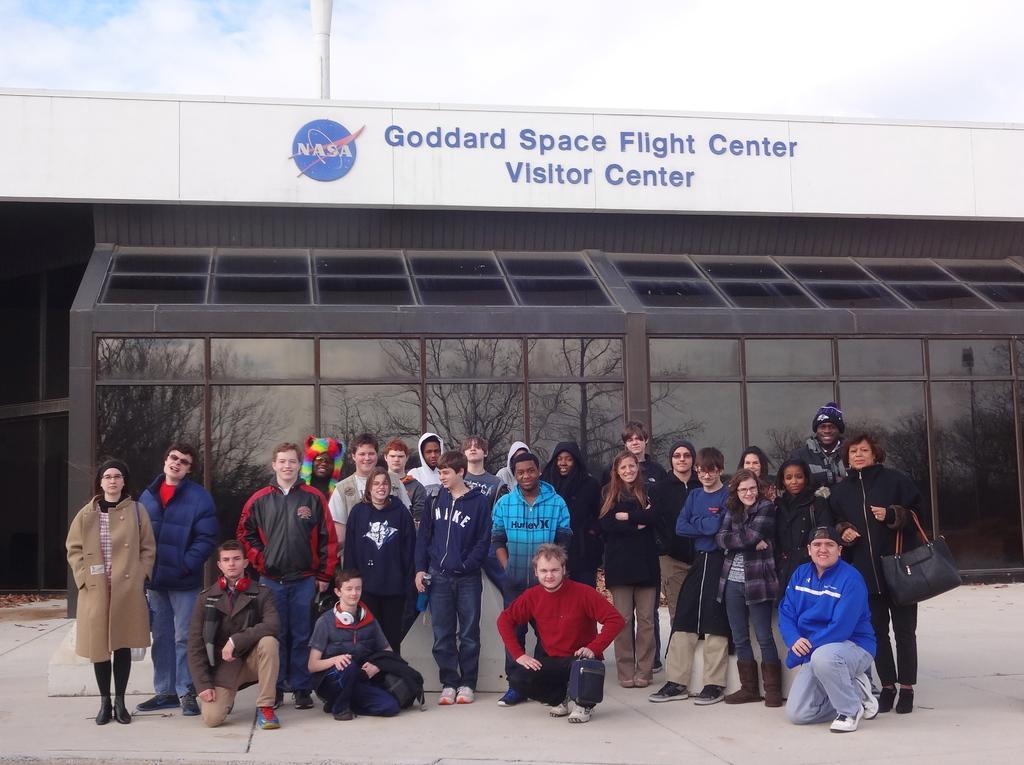Can you describe this image briefly? In this image at front there are persons standing on the road. At the back side there is a buildings and at the top there is sky. 